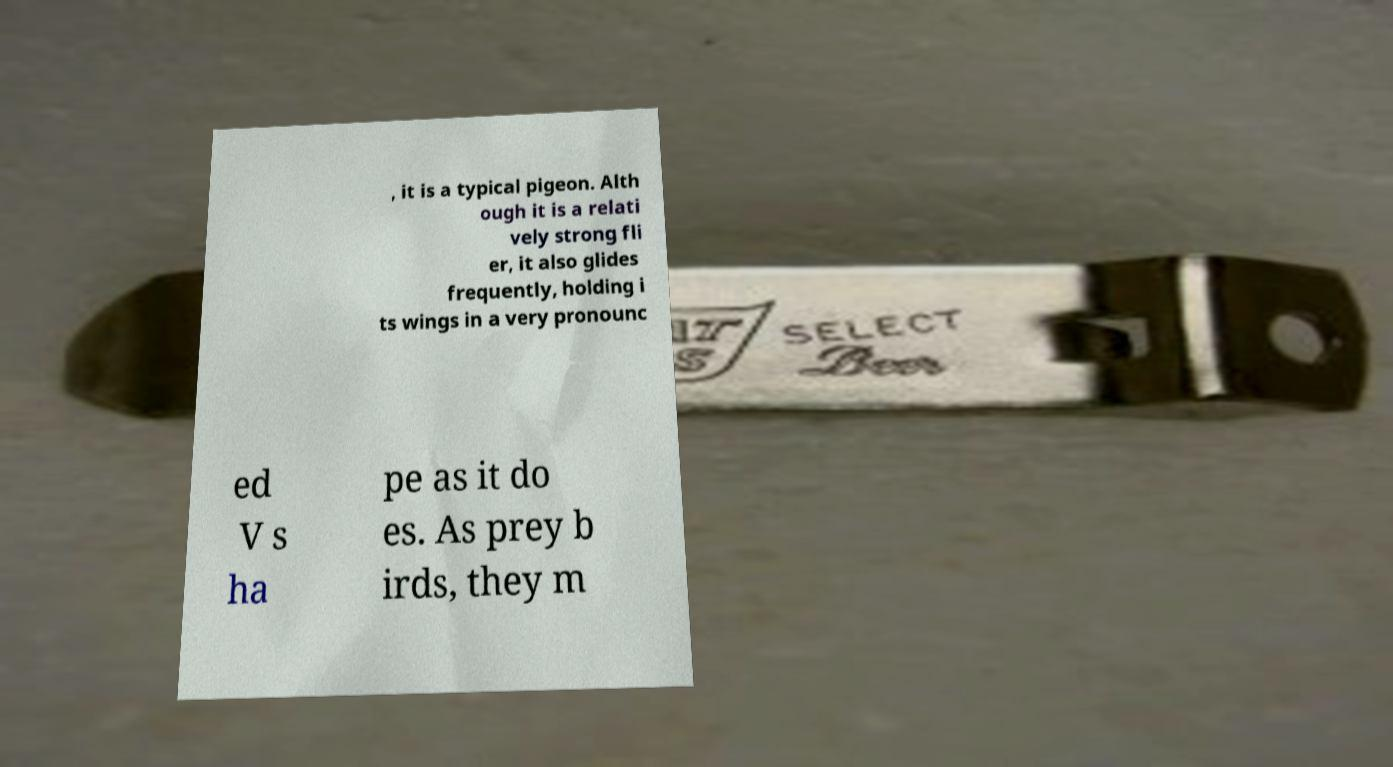Can you accurately transcribe the text from the provided image for me? , it is a typical pigeon. Alth ough it is a relati vely strong fli er, it also glides frequently, holding i ts wings in a very pronounc ed V s ha pe as it do es. As prey b irds, they m 